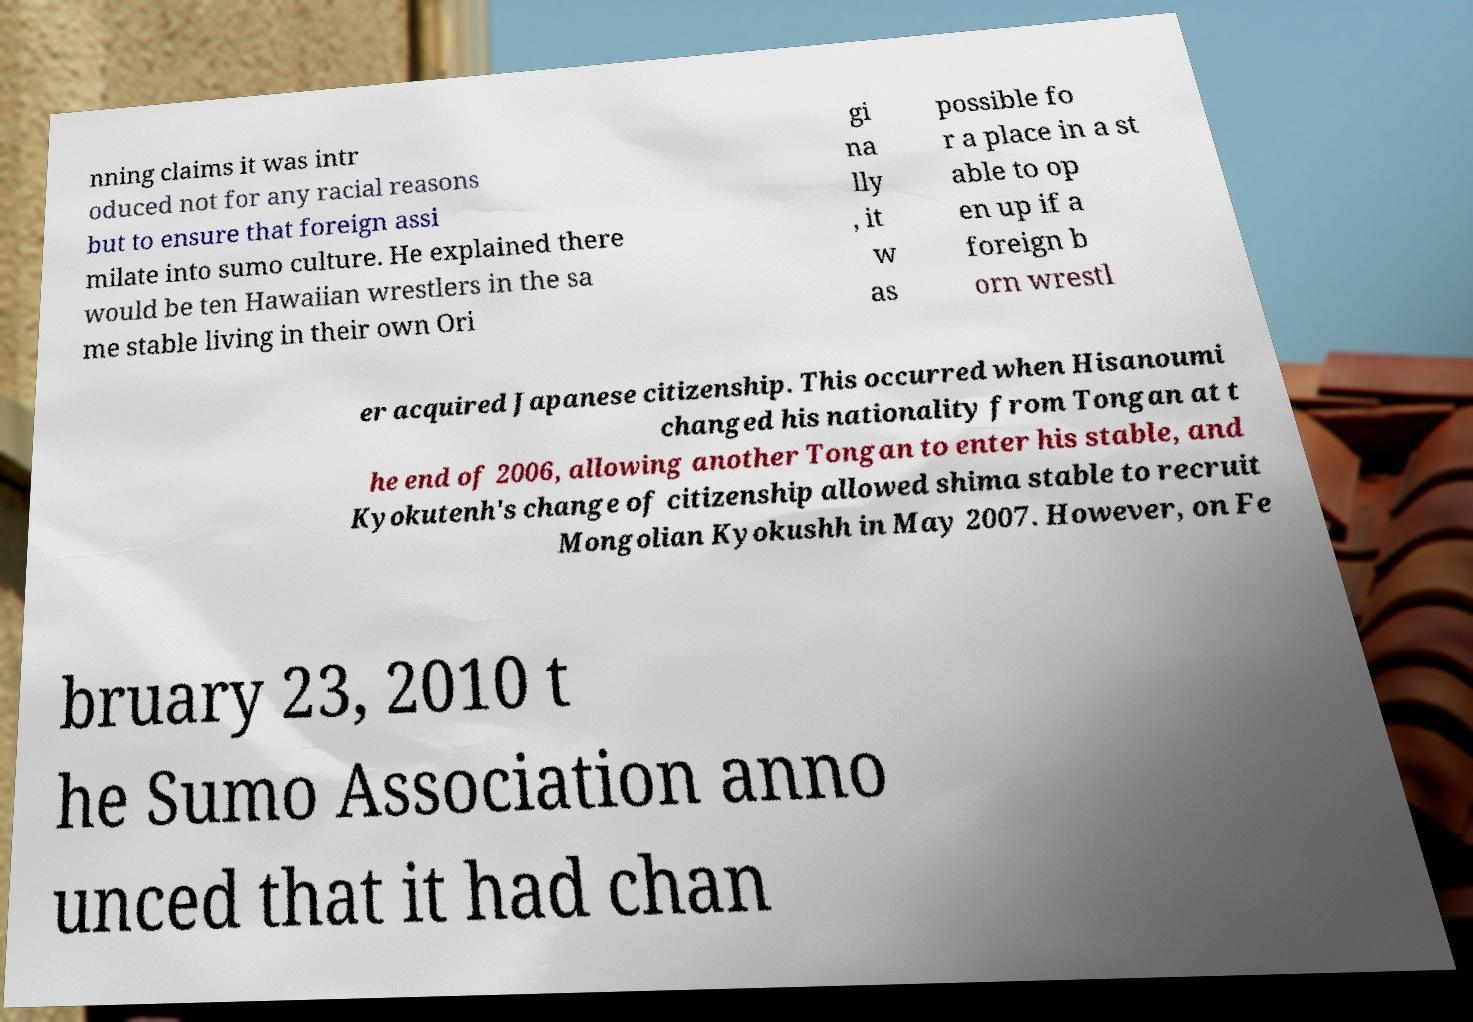Can you read and provide the text displayed in the image?This photo seems to have some interesting text. Can you extract and type it out for me? nning claims it was intr oduced not for any racial reasons but to ensure that foreign assi milate into sumo culture. He explained there would be ten Hawaiian wrestlers in the sa me stable living in their own Ori gi na lly , it w as possible fo r a place in a st able to op en up if a foreign b orn wrestl er acquired Japanese citizenship. This occurred when Hisanoumi changed his nationality from Tongan at t he end of 2006, allowing another Tongan to enter his stable, and Kyokutenh's change of citizenship allowed shima stable to recruit Mongolian Kyokushh in May 2007. However, on Fe bruary 23, 2010 t he Sumo Association anno unced that it had chan 